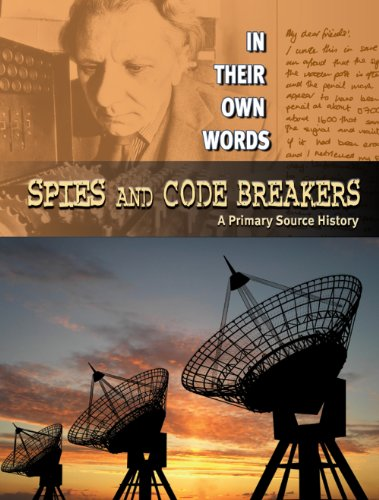Who is the intended audience for this book and why would they find it appealing? The intended audience is children, especially those interested in history and mysteries. The engaging stories of spies and code-breaking are presented in an accessible way that educates while captivating the imagination. 